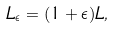Convert formula to latex. <formula><loc_0><loc_0><loc_500><loc_500>L _ { \epsilon } = ( 1 + \epsilon ) L ,</formula> 